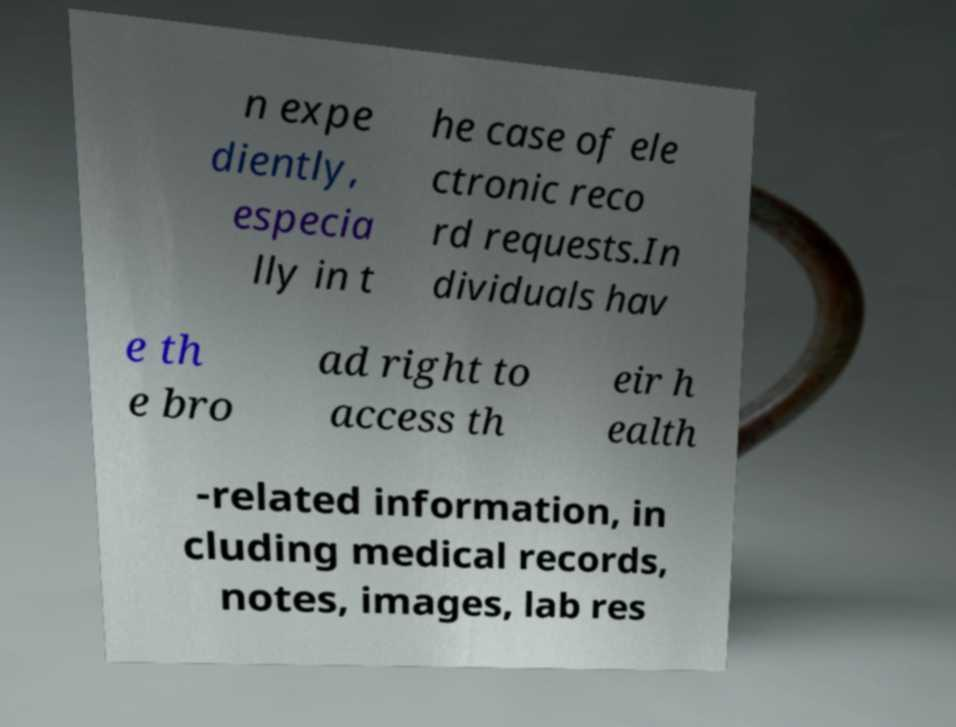Could you assist in decoding the text presented in this image and type it out clearly? n expe diently, especia lly in t he case of ele ctronic reco rd requests.In dividuals hav e th e bro ad right to access th eir h ealth -related information, in cluding medical records, notes, images, lab res 